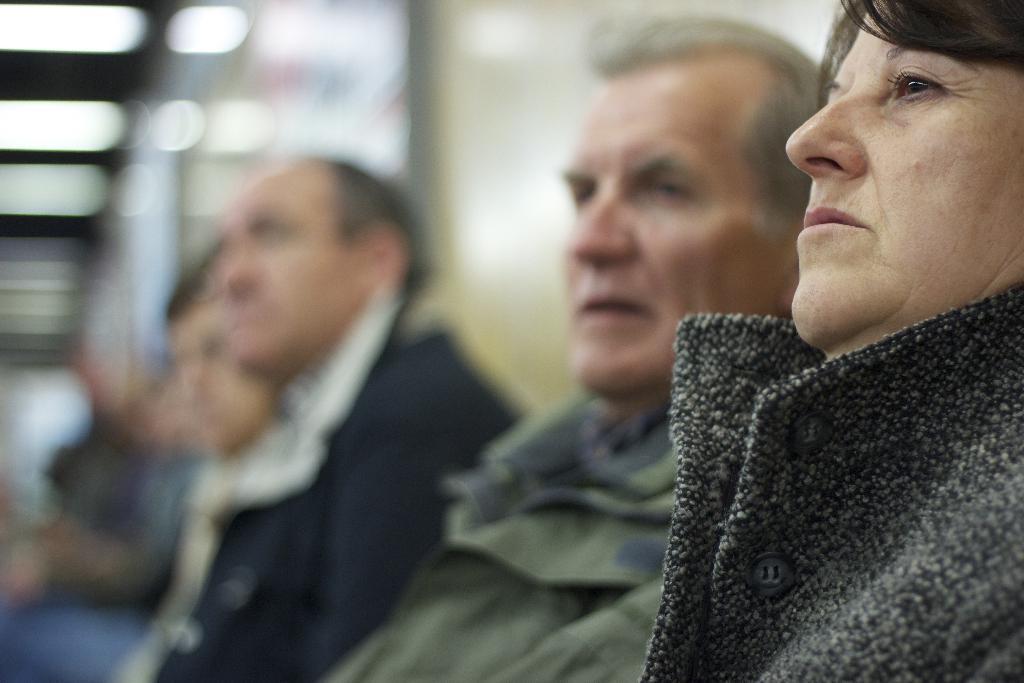Please provide a concise description of this image. In this image we can see people sitting. The background of the image is blur. 